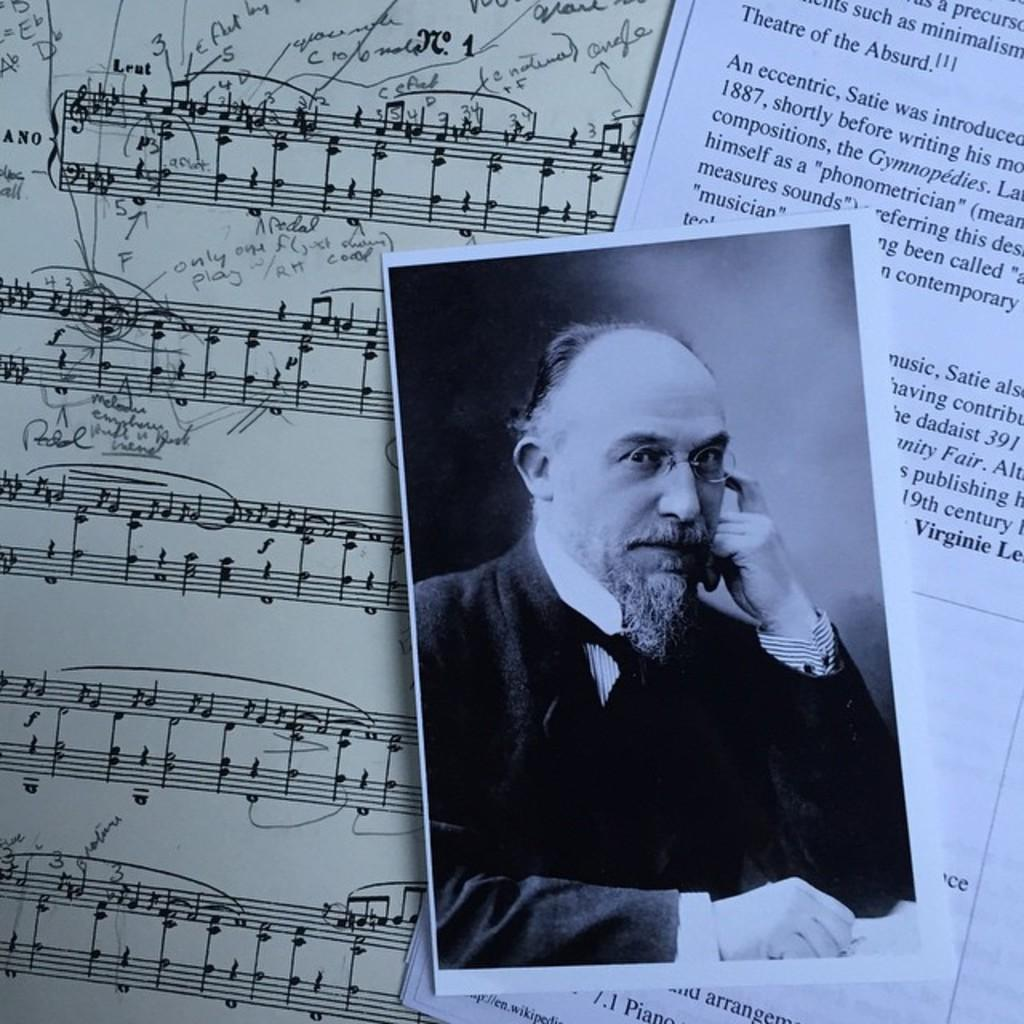What is present on the papers in the image? Something is written on the papers in the image. Can you describe the picture in the image? There is a black and white picture of a person in the image. What is the person in the picture wearing? The person in the picture is wearing a white and black colored dress. How many cows can be seen in the image? There are no cows present in the image. What type of library is depicted in the image? There is no library depicted in the image. 